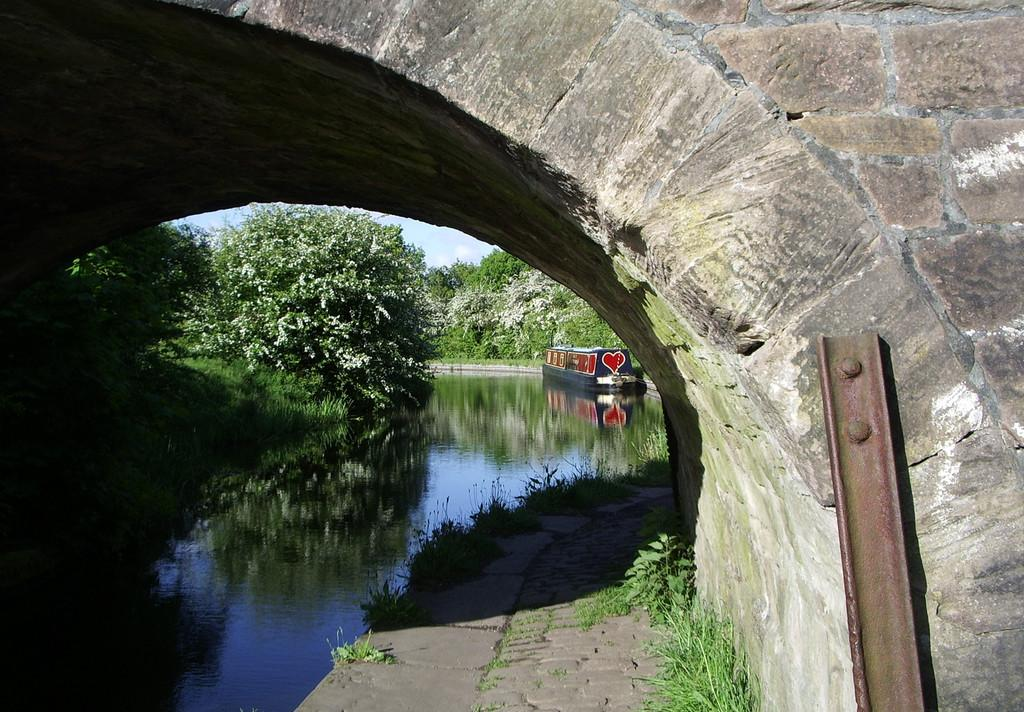What structure can be seen in the image? There is an arch in the image. What is present beneath the arch? There is water in the image, and a boat is on the water. What can be seen in the background of the image? There are trees and the sky visible in the background of the image. Is there any additional object on the right side of the image? Yes, there is an iron rod on the right side of the image. What type of approval does the writer need from the aunt in the image? There is no writer or aunt present in the image; it features an arch, water, a boat, trees, the sky, and an iron rod. 